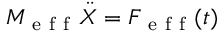Convert formula to latex. <formula><loc_0><loc_0><loc_500><loc_500>M _ { e f f } \ddot { X } = F _ { e f f } ( t )</formula> 